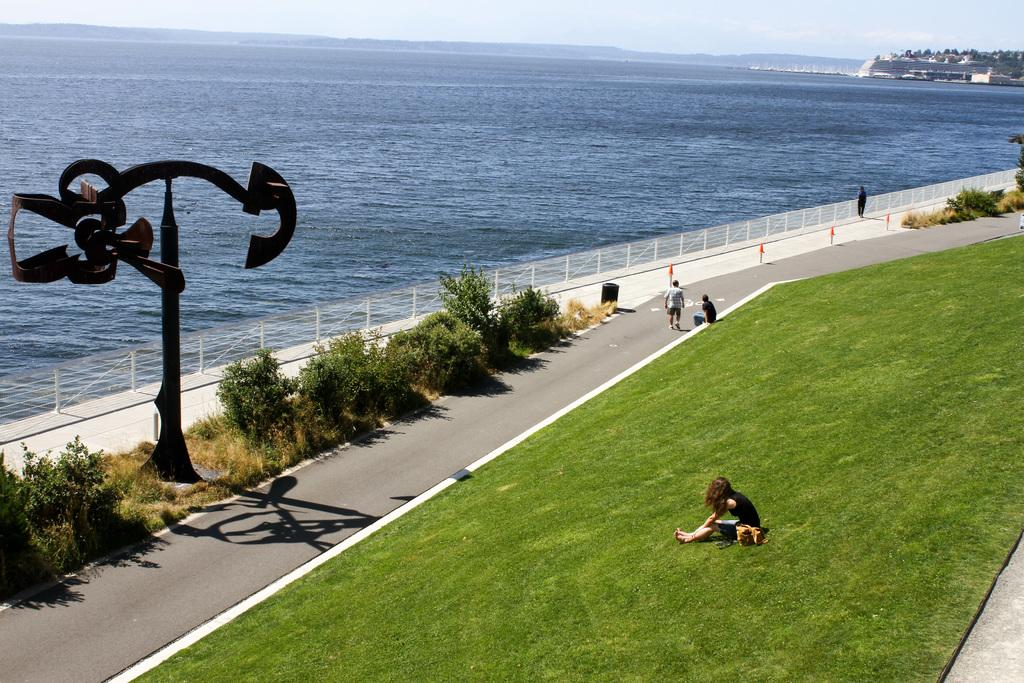How many people are in the image? There are people in the image, but the exact number is not specified. What type of ground is visible in the image? The ground has grass in the image. What kind of path can be seen in the image? There is a path in the image. What objects are present on the ground? There are objects on the ground in the image. What structures are visible in the image? There are poles and fencing in the image. What natural feature can be seen in the image? There is water visible in the image, and mountains are also present. What is visible in the sky? The sky is visible in the image, and there are clouds in the sky. What type of flag is waving in the wind in the image? There is no flag present in the image, and therefore no flag can be seen waving in the wind. What tool is being used to rake the grass in the image? There is no rake or any indication of grass-raking activity in the image. 